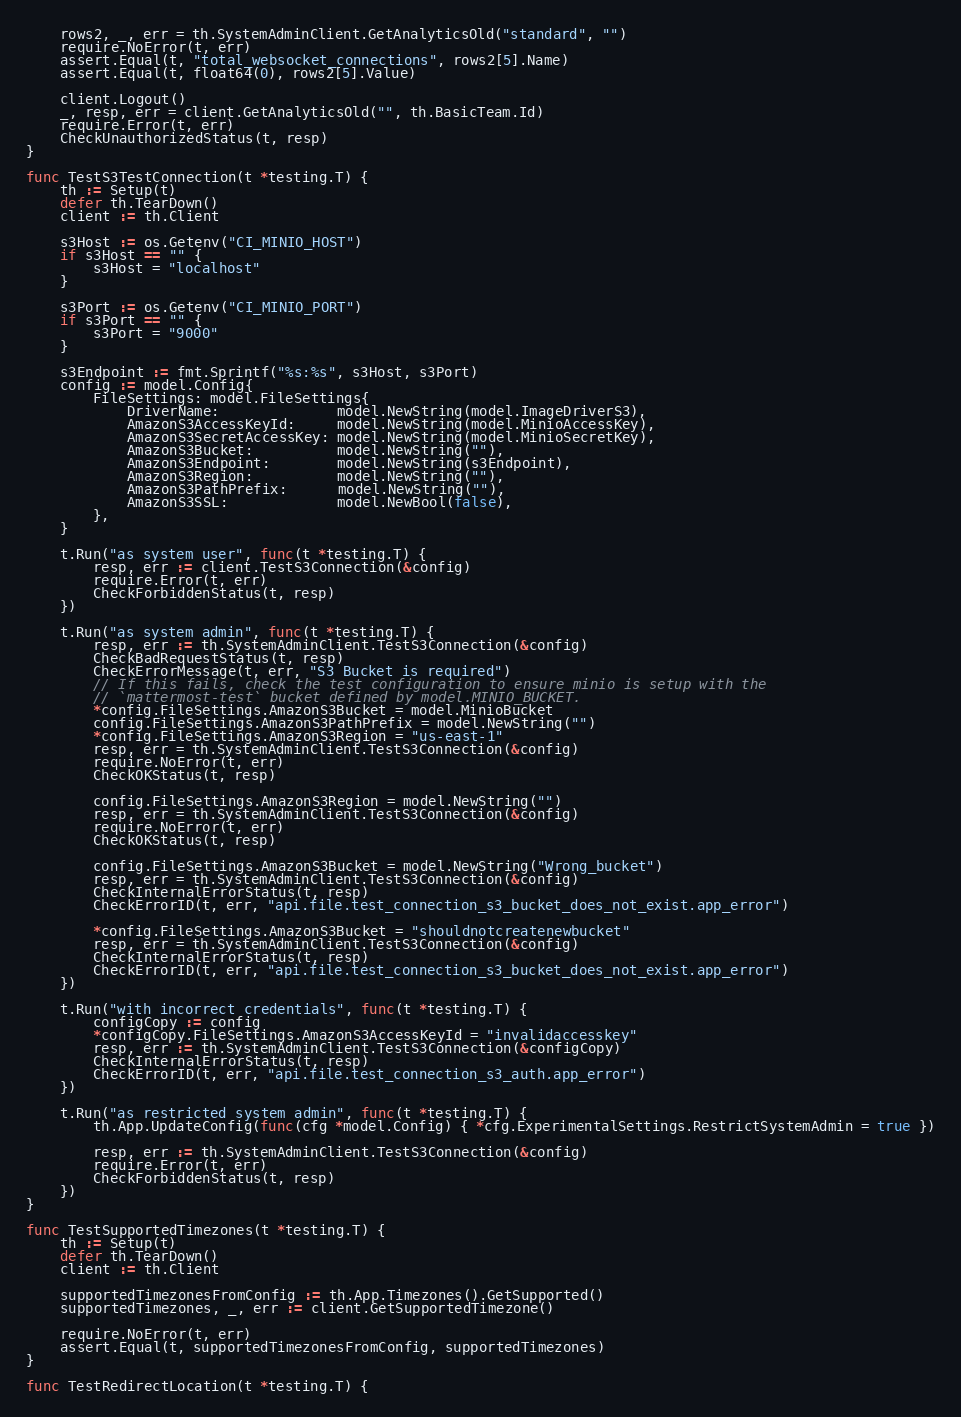<code> <loc_0><loc_0><loc_500><loc_500><_Go_>
	rows2, _, err = th.SystemAdminClient.GetAnalyticsOld("standard", "")
	require.NoError(t, err)
	assert.Equal(t, "total_websocket_connections", rows2[5].Name)
	assert.Equal(t, float64(0), rows2[5].Value)

	client.Logout()
	_, resp, err = client.GetAnalyticsOld("", th.BasicTeam.Id)
	require.Error(t, err)
	CheckUnauthorizedStatus(t, resp)
}

func TestS3TestConnection(t *testing.T) {
	th := Setup(t)
	defer th.TearDown()
	client := th.Client

	s3Host := os.Getenv("CI_MINIO_HOST")
	if s3Host == "" {
		s3Host = "localhost"
	}

	s3Port := os.Getenv("CI_MINIO_PORT")
	if s3Port == "" {
		s3Port = "9000"
	}

	s3Endpoint := fmt.Sprintf("%s:%s", s3Host, s3Port)
	config := model.Config{
		FileSettings: model.FileSettings{
			DriverName:              model.NewString(model.ImageDriverS3),
			AmazonS3AccessKeyId:     model.NewString(model.MinioAccessKey),
			AmazonS3SecretAccessKey: model.NewString(model.MinioSecretKey),
			AmazonS3Bucket:          model.NewString(""),
			AmazonS3Endpoint:        model.NewString(s3Endpoint),
			AmazonS3Region:          model.NewString(""),
			AmazonS3PathPrefix:      model.NewString(""),
			AmazonS3SSL:             model.NewBool(false),
		},
	}

	t.Run("as system user", func(t *testing.T) {
		resp, err := client.TestS3Connection(&config)
		require.Error(t, err)
		CheckForbiddenStatus(t, resp)
	})

	t.Run("as system admin", func(t *testing.T) {
		resp, err := th.SystemAdminClient.TestS3Connection(&config)
		CheckBadRequestStatus(t, resp)
		CheckErrorMessage(t, err, "S3 Bucket is required")
		// If this fails, check the test configuration to ensure minio is setup with the
		// `mattermost-test` bucket defined by model.MINIO_BUCKET.
		*config.FileSettings.AmazonS3Bucket = model.MinioBucket
		config.FileSettings.AmazonS3PathPrefix = model.NewString("")
		*config.FileSettings.AmazonS3Region = "us-east-1"
		resp, err = th.SystemAdminClient.TestS3Connection(&config)
		require.NoError(t, err)
		CheckOKStatus(t, resp)

		config.FileSettings.AmazonS3Region = model.NewString("")
		resp, err = th.SystemAdminClient.TestS3Connection(&config)
		require.NoError(t, err)
		CheckOKStatus(t, resp)

		config.FileSettings.AmazonS3Bucket = model.NewString("Wrong_bucket")
		resp, err = th.SystemAdminClient.TestS3Connection(&config)
		CheckInternalErrorStatus(t, resp)
		CheckErrorID(t, err, "api.file.test_connection_s3_bucket_does_not_exist.app_error")

		*config.FileSettings.AmazonS3Bucket = "shouldnotcreatenewbucket"
		resp, err = th.SystemAdminClient.TestS3Connection(&config)
		CheckInternalErrorStatus(t, resp)
		CheckErrorID(t, err, "api.file.test_connection_s3_bucket_does_not_exist.app_error")
	})

	t.Run("with incorrect credentials", func(t *testing.T) {
		configCopy := config
		*configCopy.FileSettings.AmazonS3AccessKeyId = "invalidaccesskey"
		resp, err := th.SystemAdminClient.TestS3Connection(&configCopy)
		CheckInternalErrorStatus(t, resp)
		CheckErrorID(t, err, "api.file.test_connection_s3_auth.app_error")
	})

	t.Run("as restricted system admin", func(t *testing.T) {
		th.App.UpdateConfig(func(cfg *model.Config) { *cfg.ExperimentalSettings.RestrictSystemAdmin = true })

		resp, err := th.SystemAdminClient.TestS3Connection(&config)
		require.Error(t, err)
		CheckForbiddenStatus(t, resp)
	})
}

func TestSupportedTimezones(t *testing.T) {
	th := Setup(t)
	defer th.TearDown()
	client := th.Client

	supportedTimezonesFromConfig := th.App.Timezones().GetSupported()
	supportedTimezones, _, err := client.GetSupportedTimezone()

	require.NoError(t, err)
	assert.Equal(t, supportedTimezonesFromConfig, supportedTimezones)
}

func TestRedirectLocation(t *testing.T) {</code> 